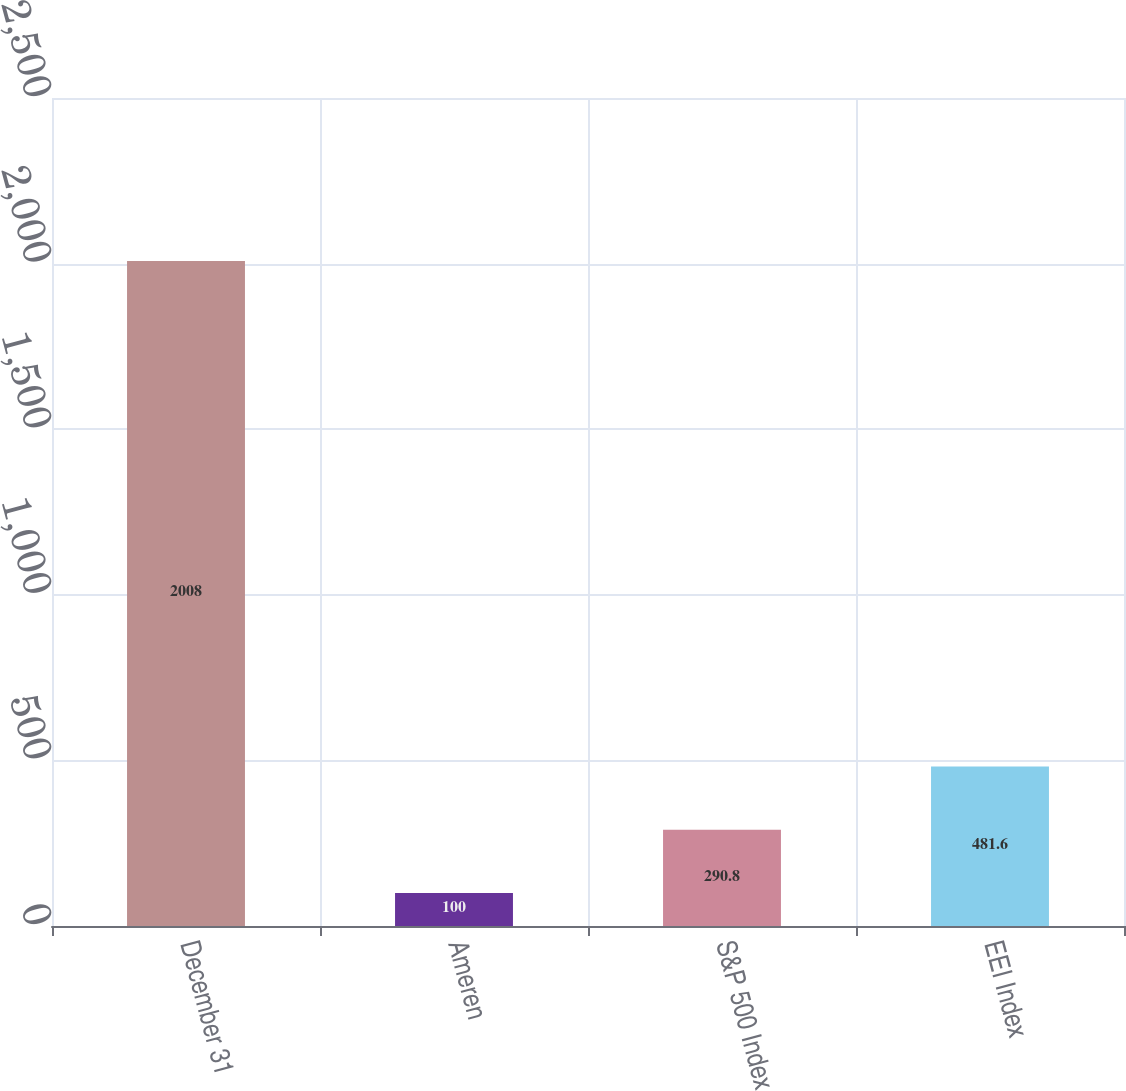<chart> <loc_0><loc_0><loc_500><loc_500><bar_chart><fcel>December 31<fcel>Ameren<fcel>S&P 500 Index<fcel>EEI Index<nl><fcel>2008<fcel>100<fcel>290.8<fcel>481.6<nl></chart> 